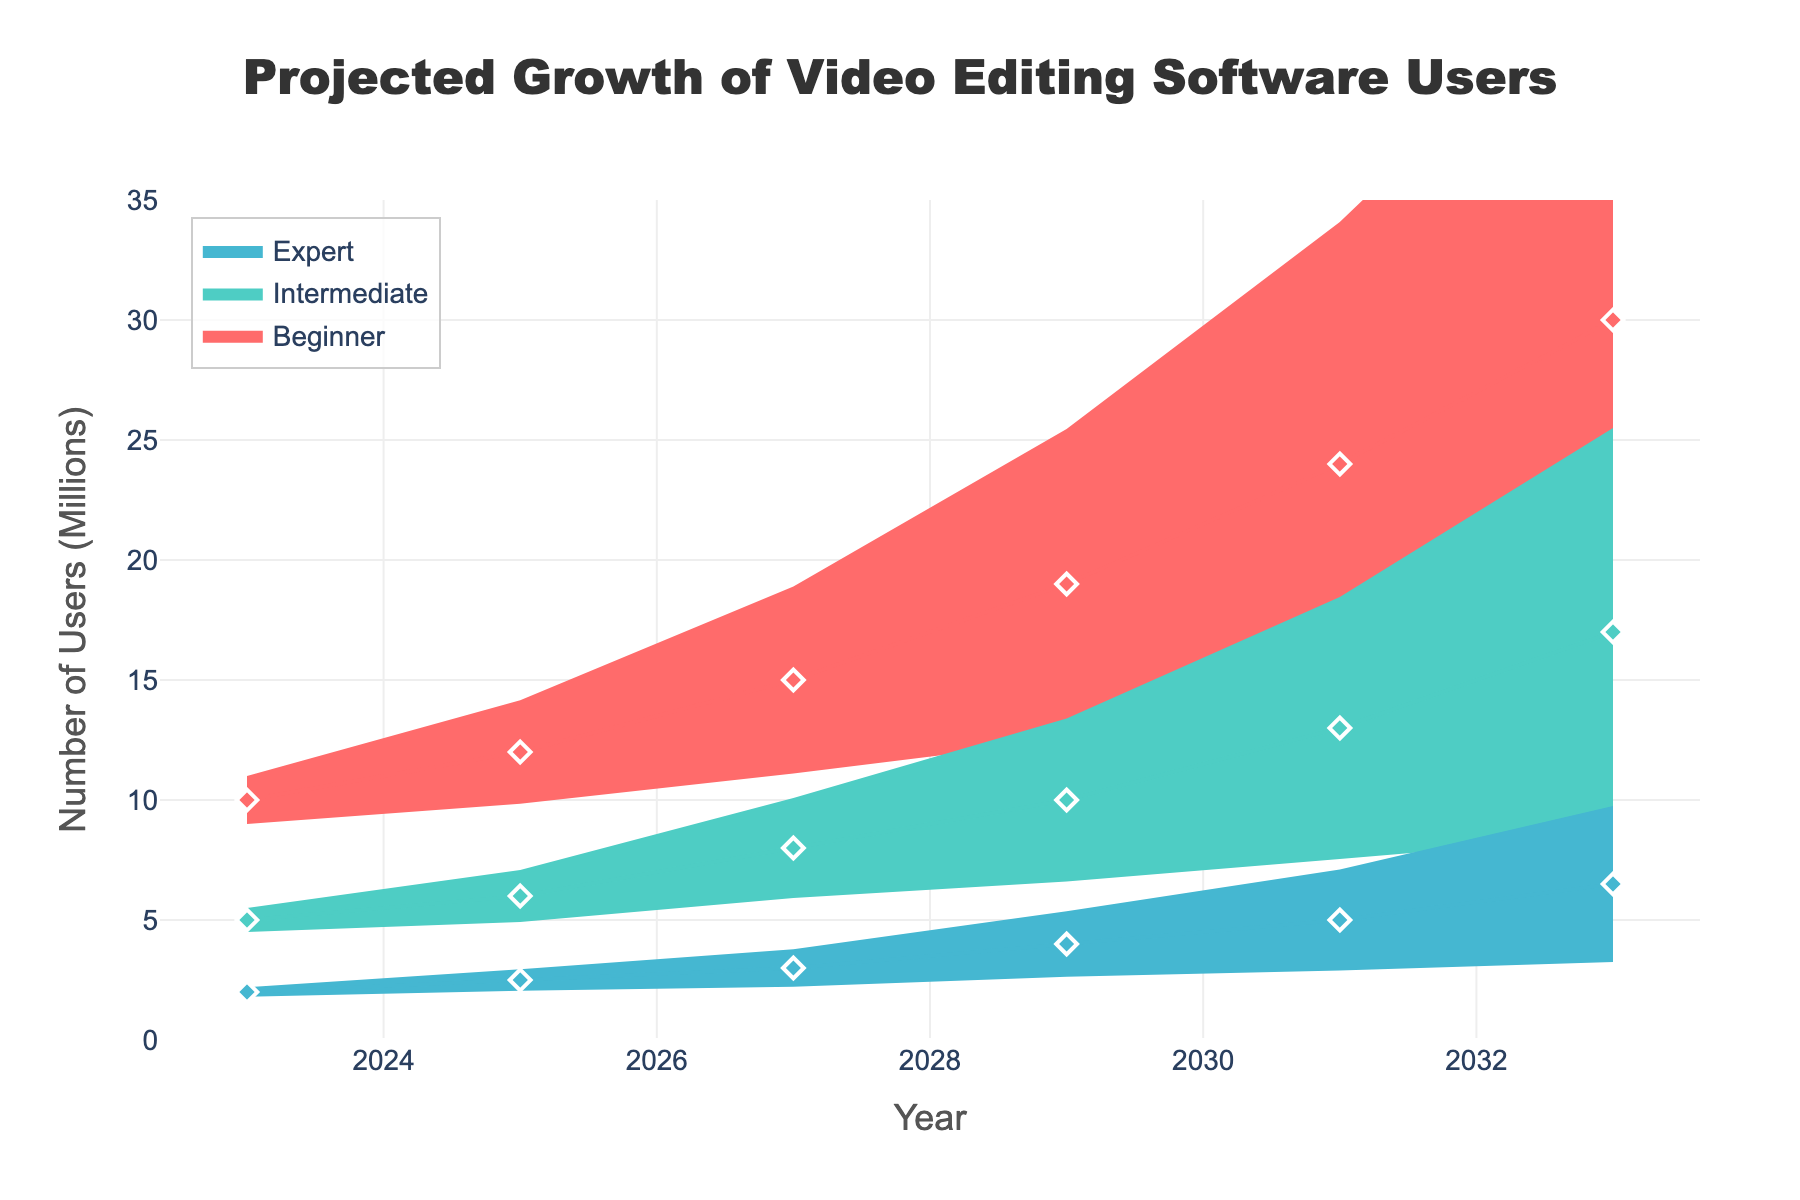What's the title of the chart? The title of the chart is typically found at the top and center of the chart. In this case, it serves to briefly describe what the chart is about.
Answer: Projected Growth of Video Editing Software Users How many user categories are there? By looking at the legend and the different colored regions or lines in the chart, we see there are three categories: Beginner, Intermediate, and Expert.
Answer: 3 Which user category is projected to have the highest number of users in 2033? By following the line trend for each category to the year 2033 on the x-axis, and looking at the y-axis value, we notice that the 'Beginner' category has the highest point.
Answer: Beginner What is the range of projected users for Intermediate category in 2029? The range is found between the lower and upper bounds of the shaded area for the Intermediate category in 2029.
Answer: 5 to 15 million How many users are projected for the Expert category in 2027? We follow the Expert line to the year 2027 on the x-axis and look at the corresponding y-axis value.
Answer: 3 million By how much is the number of projected Beginner users expected to grow from 2023 to 2031? Subtract the number of Beginner users in 2023 from the number in 2031: 24 million (2031) - 10 million (2023).
Answer: 14 million Which year shows the largest increase in projected Expert users compared to the previous year? Calculate the increase for each period: (2.5-2) for 2025, (3-2.5) for 2027, (4-3) for 2029, (5-4) for 2031, (6.5-5) for 2033. The largest increase is from 2031 to 2033.
Answer: 2033 At what year do Intermediate users surpass 10 million in projection? Follow the Intermediate line to see where it exceeds the 10 million mark on the y-axis.
Answer: 2029 What's the total number of projected users for all categories in 2029? Add the projected numbers in 2029 for all categories: Beginner: 19 + Intermediate: 10 + Expert: 4 = 33 million.
Answer: 33 million Between 2023 and 2033, which category shows the most significant relative growth? Calculate the relative growth for each category using (Future Value - Initial Value) / Initial Value: Beginner: (30-10)/10 = 2, Intermediate: (17-5)/5 = 2.4, Expert: (6.5-2)/2 = 2.25. Intermediate has the highest growth rate.
Answer: Intermediate 